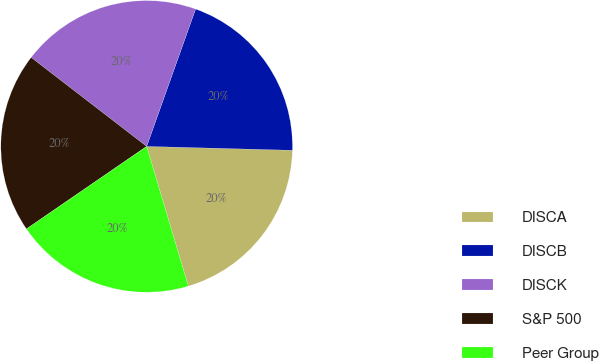<chart> <loc_0><loc_0><loc_500><loc_500><pie_chart><fcel>DISCA<fcel>DISCB<fcel>DISCK<fcel>S&P 500<fcel>Peer Group<nl><fcel>19.96%<fcel>19.98%<fcel>20.0%<fcel>20.02%<fcel>20.04%<nl></chart> 